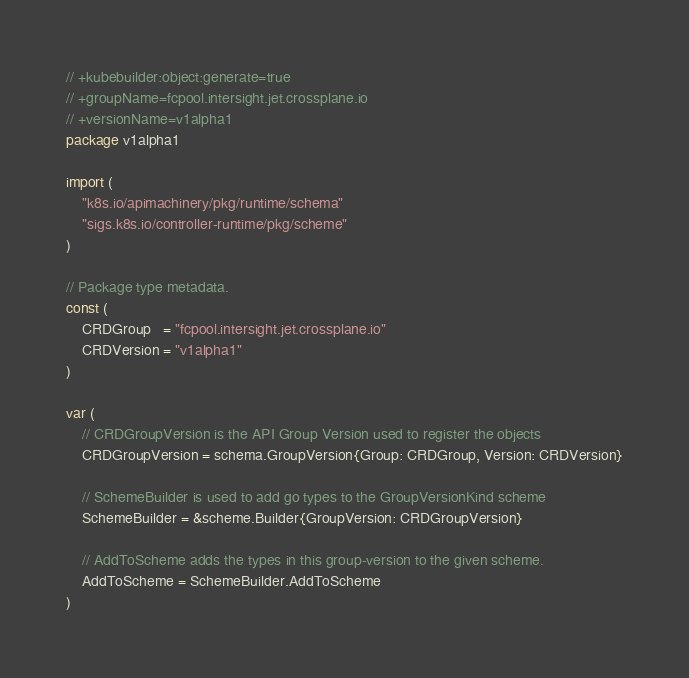Convert code to text. <code><loc_0><loc_0><loc_500><loc_500><_Go_>
// +kubebuilder:object:generate=true
// +groupName=fcpool.intersight.jet.crossplane.io
// +versionName=v1alpha1
package v1alpha1

import (
	"k8s.io/apimachinery/pkg/runtime/schema"
	"sigs.k8s.io/controller-runtime/pkg/scheme"
)

// Package type metadata.
const (
	CRDGroup   = "fcpool.intersight.jet.crossplane.io"
	CRDVersion = "v1alpha1"
)

var (
	// CRDGroupVersion is the API Group Version used to register the objects
	CRDGroupVersion = schema.GroupVersion{Group: CRDGroup, Version: CRDVersion}

	// SchemeBuilder is used to add go types to the GroupVersionKind scheme
	SchemeBuilder = &scheme.Builder{GroupVersion: CRDGroupVersion}

	// AddToScheme adds the types in this group-version to the given scheme.
	AddToScheme = SchemeBuilder.AddToScheme
)
</code> 